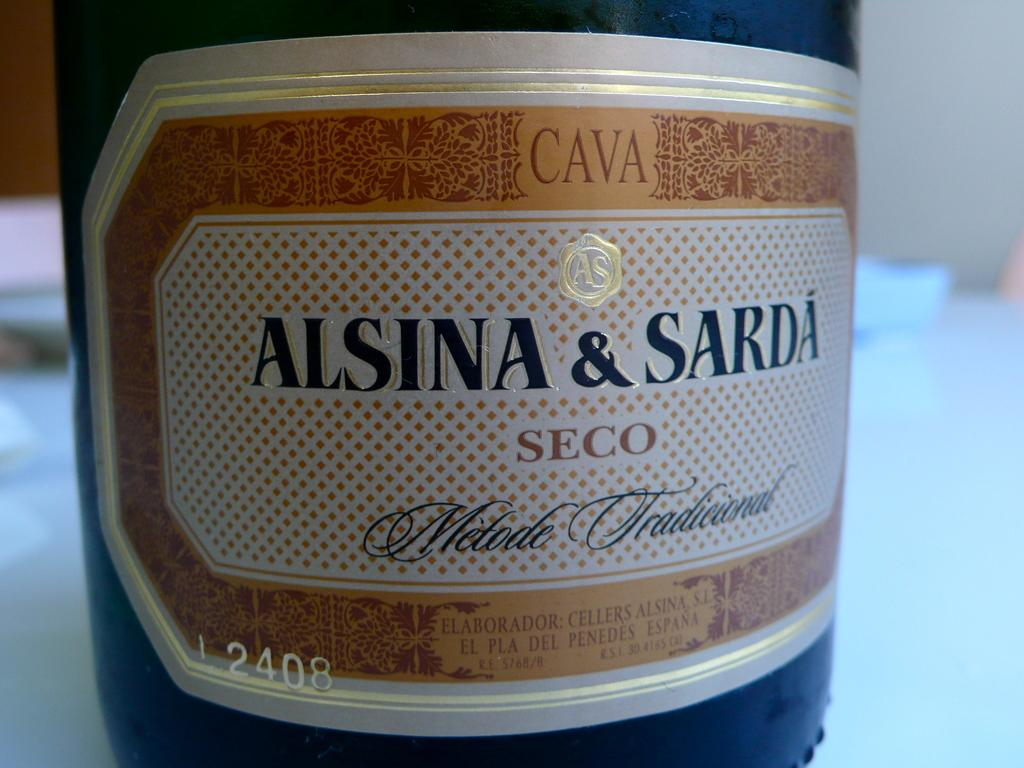What object can be seen in the image? There is a bottle in the image. What feature of the bottle is mentioned in the facts? The bottle has a label with text on it. How would you describe the background of the image? The background of the image is blurred. What type of wax can be seen dripping from the alley in the image? There is no alley or wax present in the image; it only features a bottle with a label. 